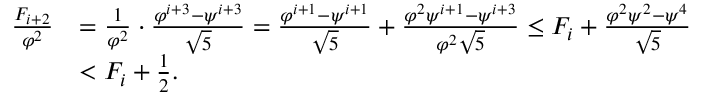Convert formula to latex. <formula><loc_0><loc_0><loc_500><loc_500>\begin{array} { r l } { \frac { F _ { i + 2 } } { \varphi ^ { 2 } } } & { = \frac { 1 } { \varphi ^ { 2 } } \cdot \frac { \varphi ^ { i + 3 } - \psi ^ { i + 3 } } { \sqrt { 5 } } = \frac { \varphi ^ { i + 1 } - \psi ^ { i + 1 } } { \sqrt { 5 } } + \frac { \varphi ^ { 2 } \psi ^ { i + 1 } - \psi ^ { i + 3 } } { \varphi ^ { 2 } \sqrt { 5 } } \leq F _ { i } + \frac { \varphi ^ { 2 } \psi ^ { 2 } - \psi ^ { 4 } } { \sqrt { 5 } } } \\ & { < F _ { i } + \frac { 1 } { 2 } . } \end{array}</formula> 